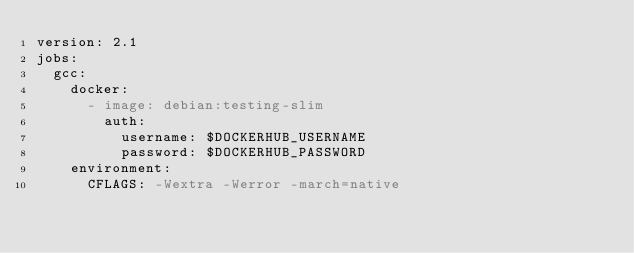<code> <loc_0><loc_0><loc_500><loc_500><_YAML_>version: 2.1
jobs:
  gcc:
    docker:
      - image: debian:testing-slim
        auth:
          username: $DOCKERHUB_USERNAME
          password: $DOCKERHUB_PASSWORD
    environment:
      CFLAGS: -Wextra -Werror -march=native</code> 